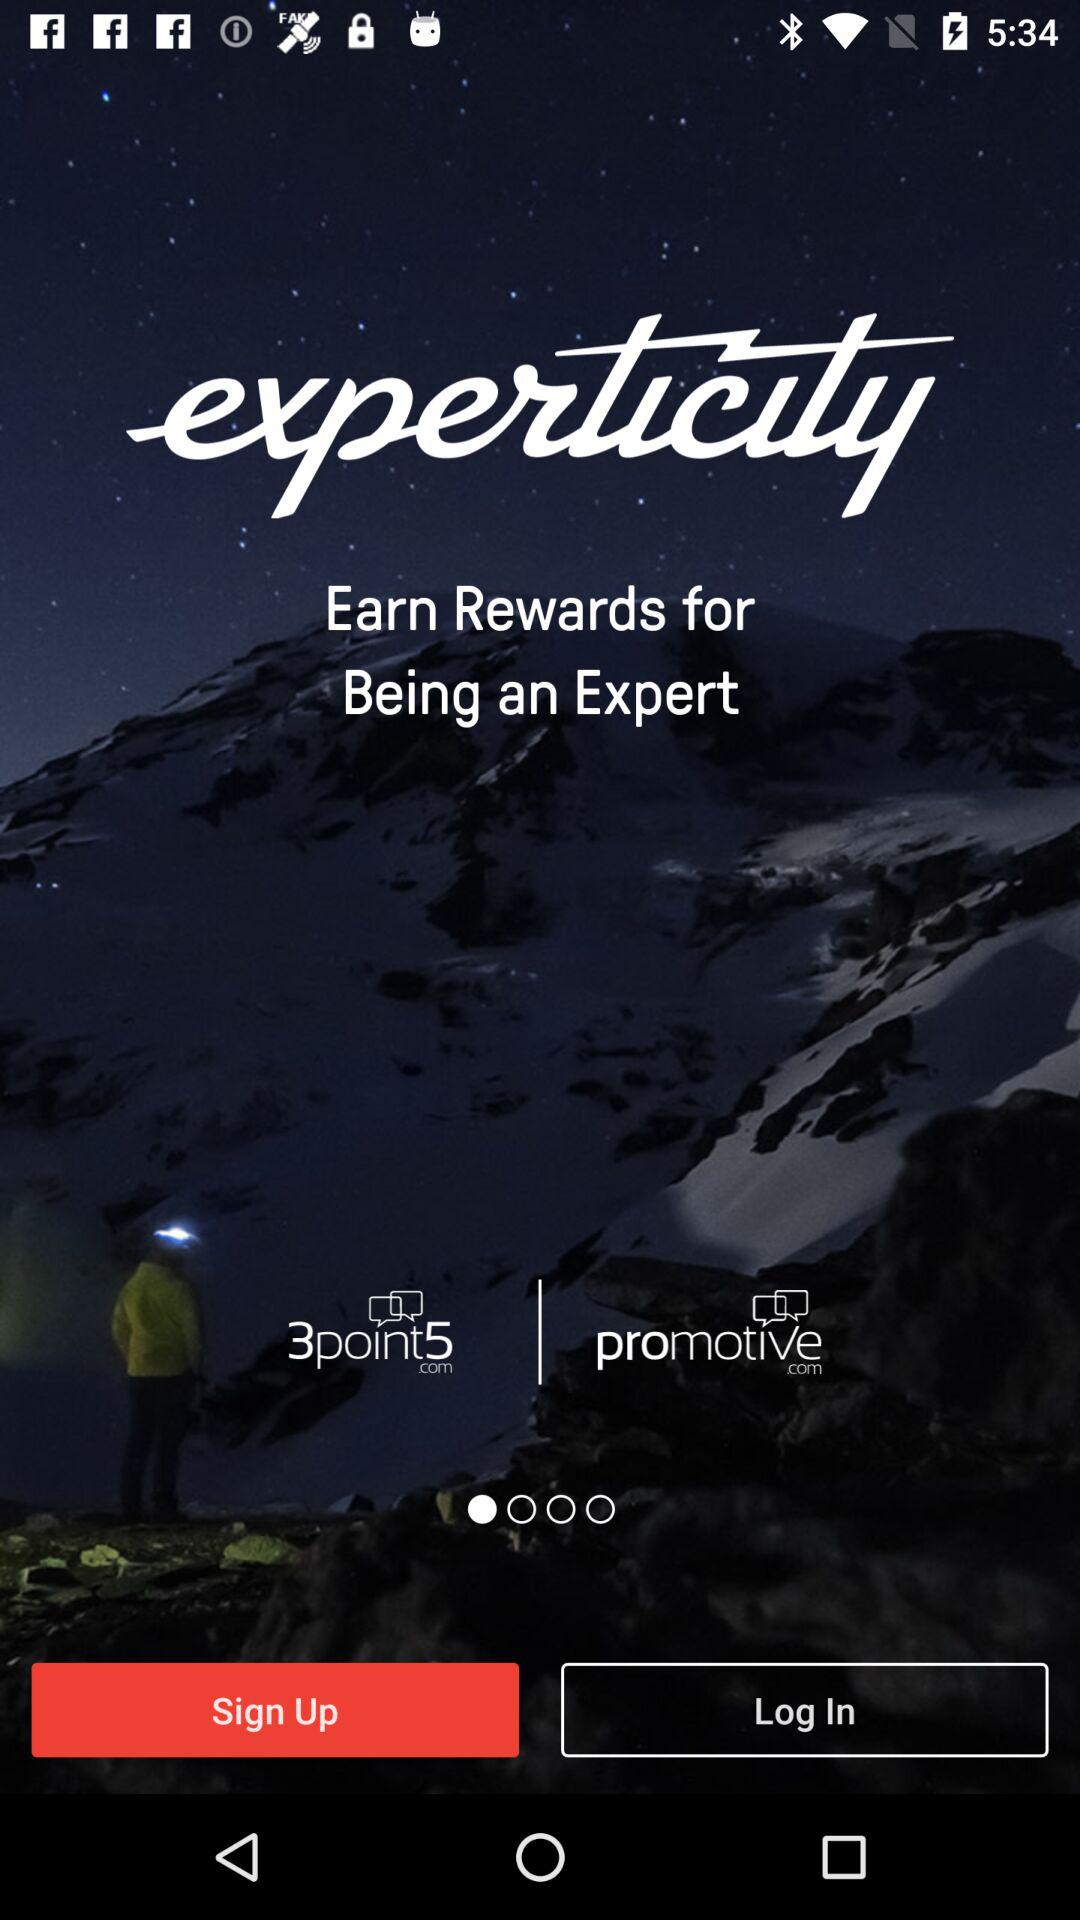What is the app name? The app name is "experticity". 